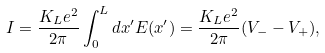<formula> <loc_0><loc_0><loc_500><loc_500>I = \frac { K _ { L } e ^ { 2 } } { 2 \pi } \int ^ { L } _ { 0 } d x ^ { \prime } E ( x ^ { \prime } ) = \frac { K _ { L } e ^ { 2 } } { 2 \pi } ( V _ { - } - V _ { + } ) ,</formula> 